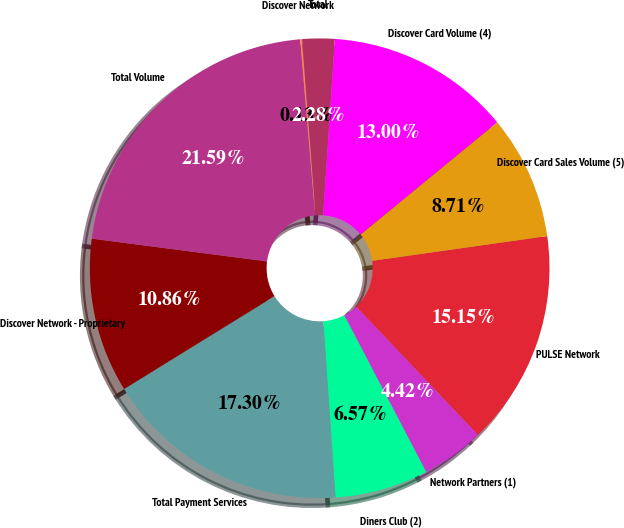Convert chart to OTSL. <chart><loc_0><loc_0><loc_500><loc_500><pie_chart><fcel>PULSE Network<fcel>Network Partners (1)<fcel>Diners Club (2)<fcel>Total Payment Services<fcel>Discover Network - Proprietary<fcel>Total Volume<fcel>Discover Network<fcel>Total<fcel>Discover Card Volume (4)<fcel>Discover Card Sales Volume (5)<nl><fcel>15.15%<fcel>4.42%<fcel>6.57%<fcel>17.3%<fcel>10.86%<fcel>21.59%<fcel>0.13%<fcel>2.28%<fcel>13.0%<fcel>8.71%<nl></chart> 